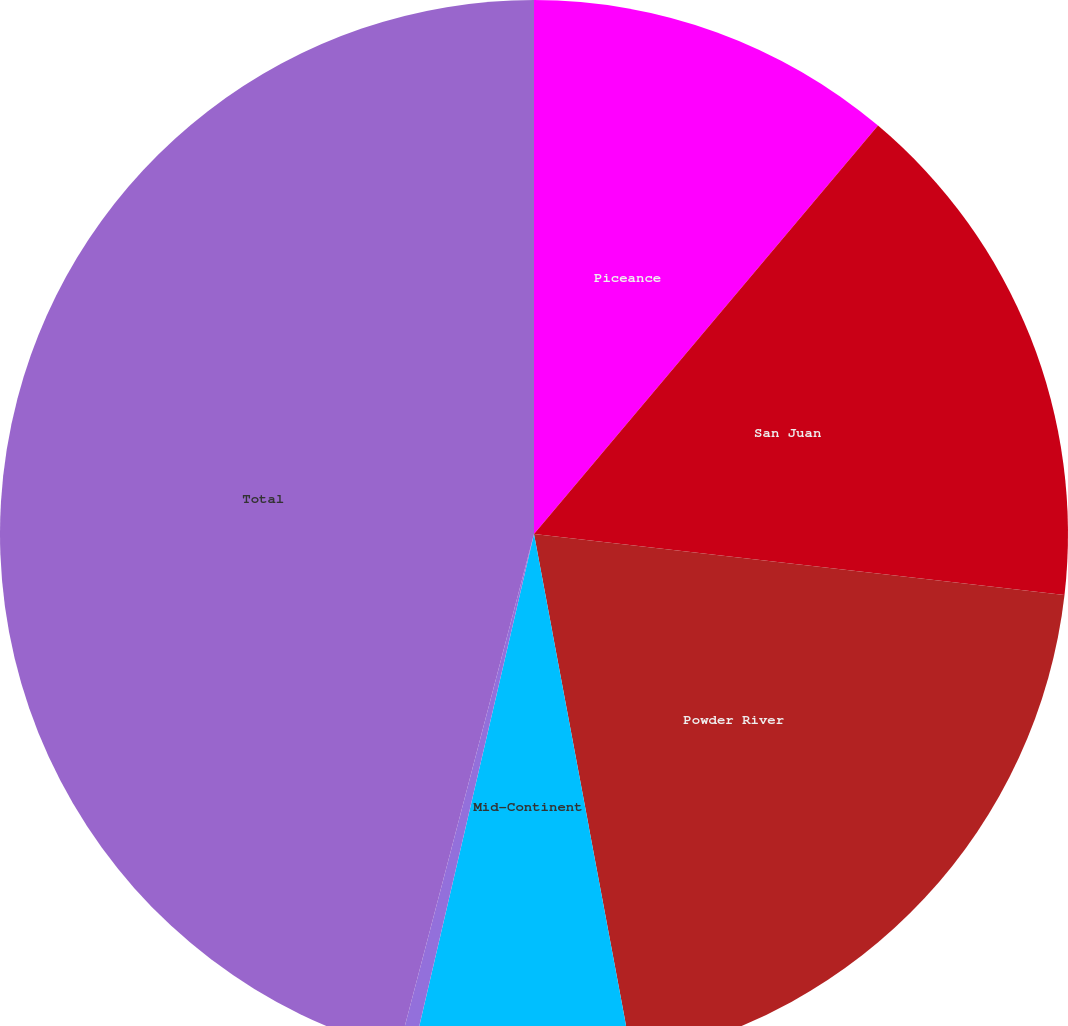Convert chart. <chart><loc_0><loc_0><loc_500><loc_500><pie_chart><fcel>Piceance<fcel>San Juan<fcel>Powder River<fcel>Mid-Continent<fcel>Other<fcel>Total<nl><fcel>11.14%<fcel>15.68%<fcel>20.23%<fcel>6.59%<fcel>0.44%<fcel>45.91%<nl></chart> 